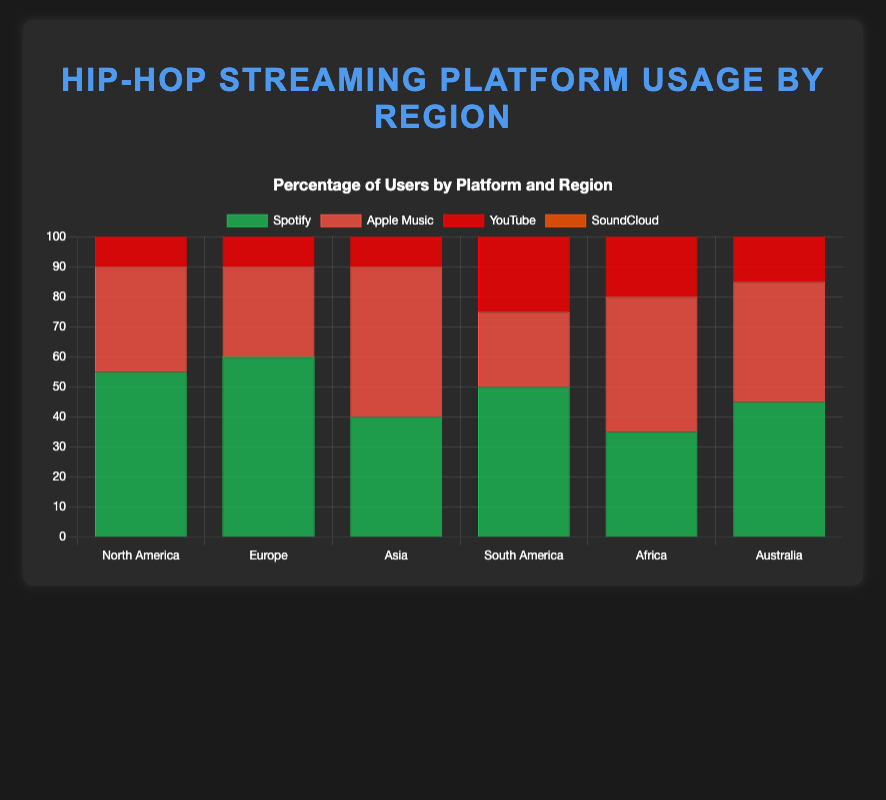What is the most used streaming platform for hip-hop music in North America? By looking at the bars for North America, the highest bar represents Spotify at 55%.
Answer: Spotify Which region has the highest percentage of Apple Music users? Observing the bars representing Apple Music across regions, Asia has the highest bar at 50%.
Answer: Asia Compare the usage of YouTube between Asia and South America. Which region has a higher percentage and by how much? In Asia, YouTube usage is 60%, whereas in South America, it is 55%. Subtracting 55 from 60 gives us the difference of 5%.
Answer: Asia, by 5% What is the total percentage of users using SoundCloud in Europe and Africa combined? SoundCloud usage in Europe is 20%, and in Africa, it is 40%. Adding these percentages gives 20 + 40 = 60%.
Answer: 60% Which streaming platform has the lowest usage in South America? Observing the bars for South America, Apple Music has the lowest usage at 25%.
Answer: Apple Music Compare the Spotify usage in North America and Africa. How much higher is it in North America? In North America, Spotify usage is 55%, and in Africa, it is 35%. Subtracting 35 from 55 gives us 20%.
Answer: 20% What is the average YouTube usage across all regions? Summing up the YouTube percentages: 45 (North America) + 40 (Europe) + 60 (Asia) + 55 (South America) + 50 (Africa) + 55 (Australia) = 305%. Dividing by 6 (number of regions) gives 305/6 ≈ 50.83%.
Answer: 50.83% Which platform has the highest variability in usage percentage across regions? By comparing the ranges of percentages across all platforms: Spotify (35-60%), Apple Music (25-50%), YouTube (40-60%), and SoundCloud (20-40%). YouTube has the widest range from 40% to 60%, a span of 20%.
Answer: YouTube Compare the usage percentages of Apple Music and SoundCloud in Australia. What is the difference? For Australia, Apple Music usage is 40%, and SoundCloud usage is 30%. Subtracting 30 from 40 gives us 10%.
Answer: 10% How does Spotify usage in Asia compare to Europe? The Spotify usage in Asia is 40%, while in Europe it is 60%. Therefore, Europe has a higher percentage by 20%.
Answer: Europe, by 20% 